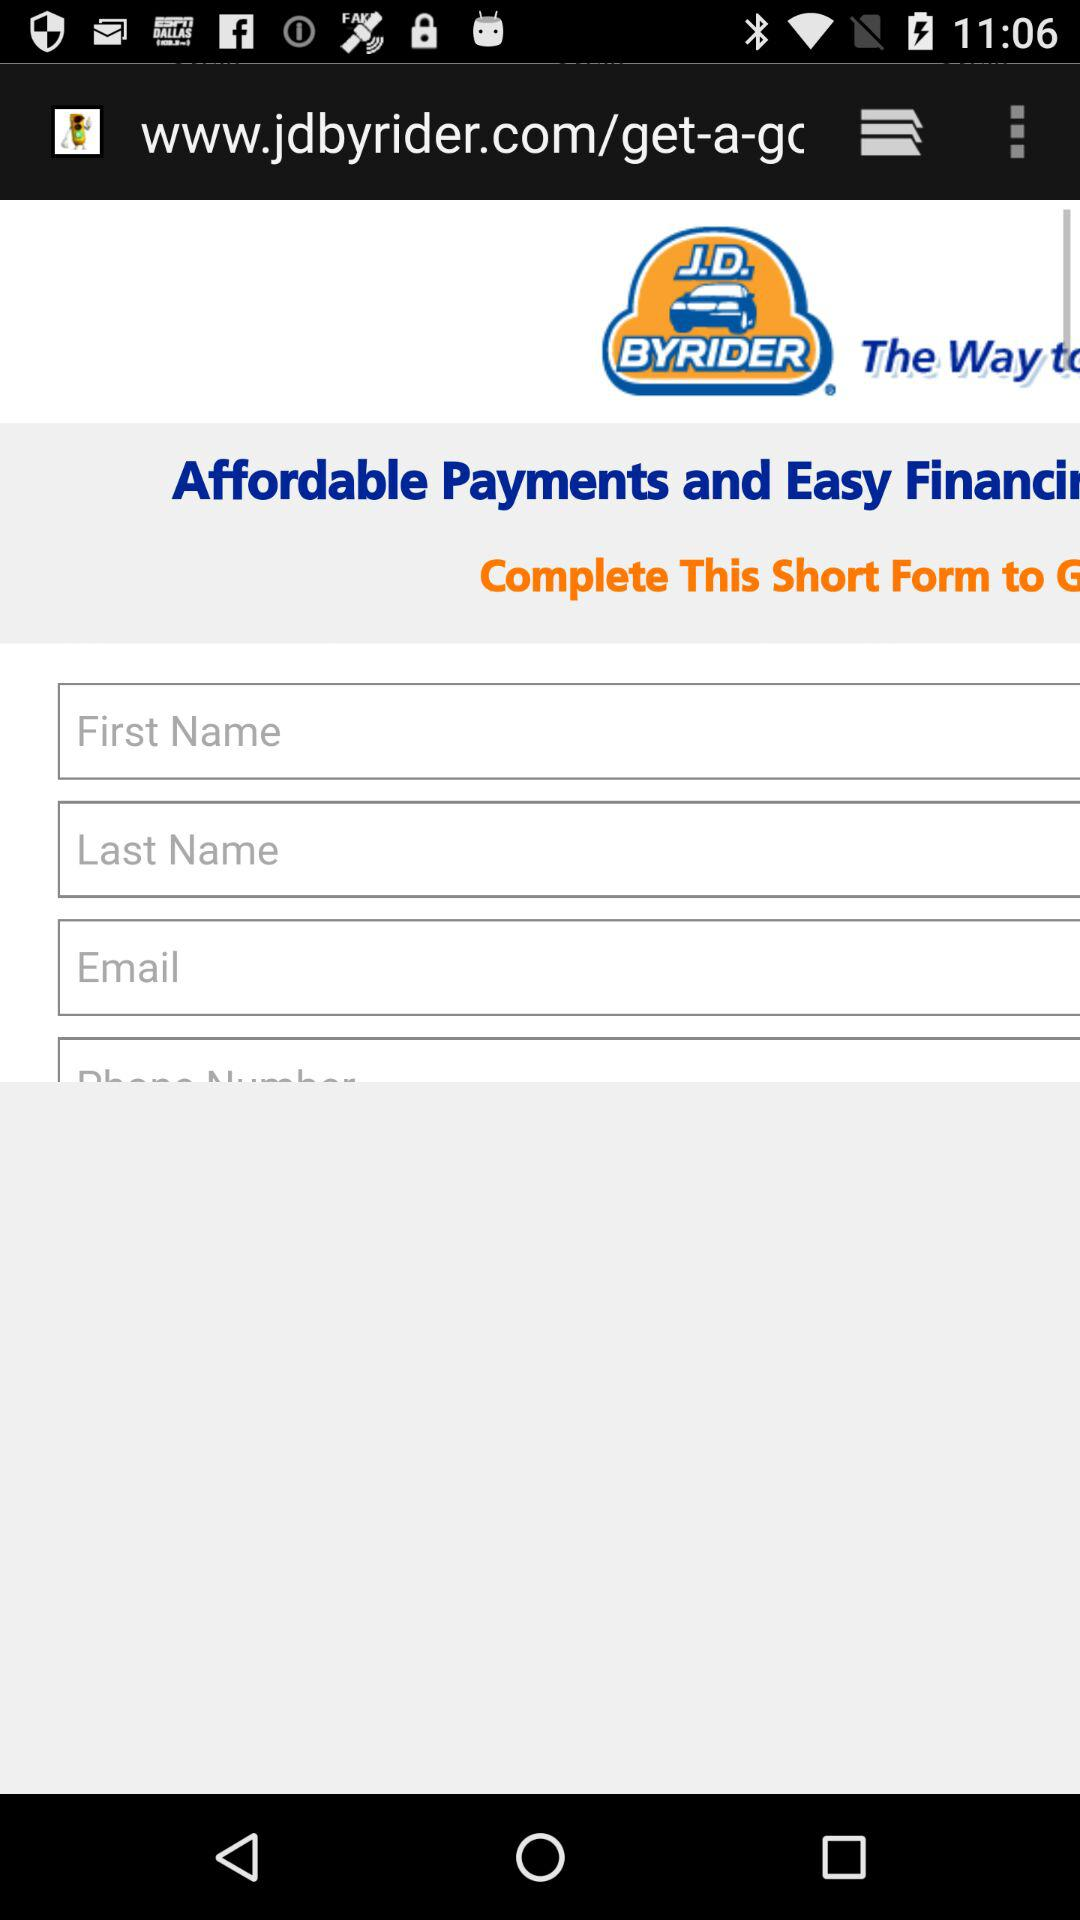What is the application name? The application name is "J.D. BYRIDER". 